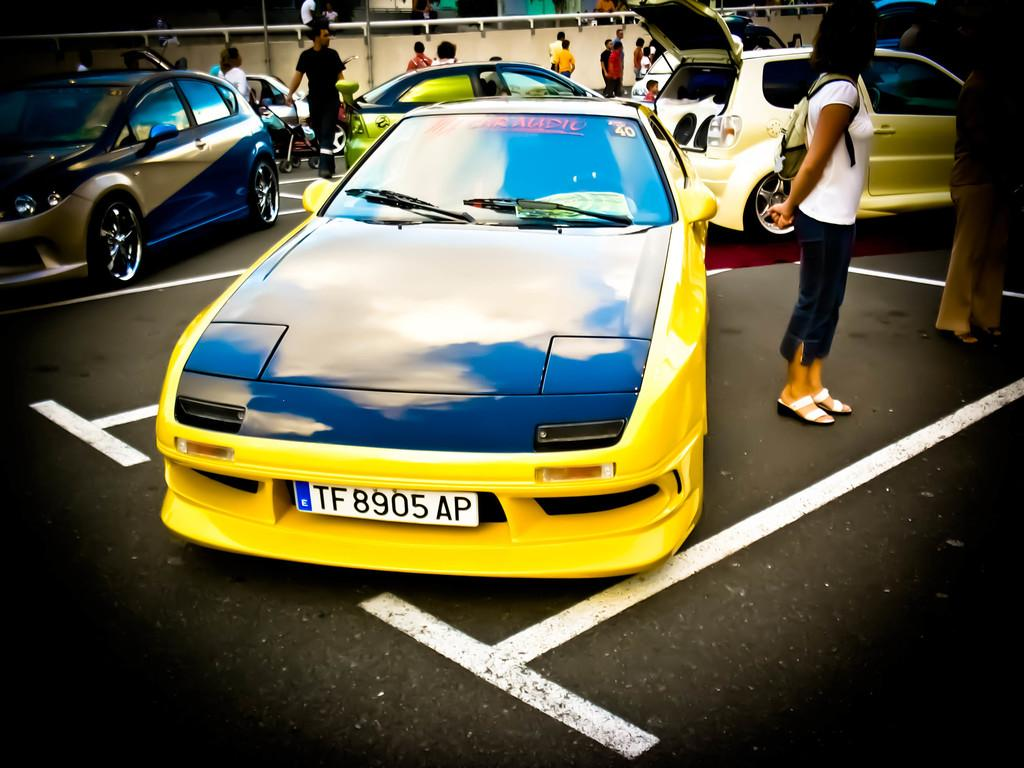What can be seen on the road in the image? There are vehicles on the road in the image. Who or what else is present in the image? There are people in the image. What can be seen in the background of the image? There is a rod and a wall in the background of the image. What type of writer is performing on the stage in the image? There is no writer or stage present in the image; it features vehicles on the road and people in the scene. 